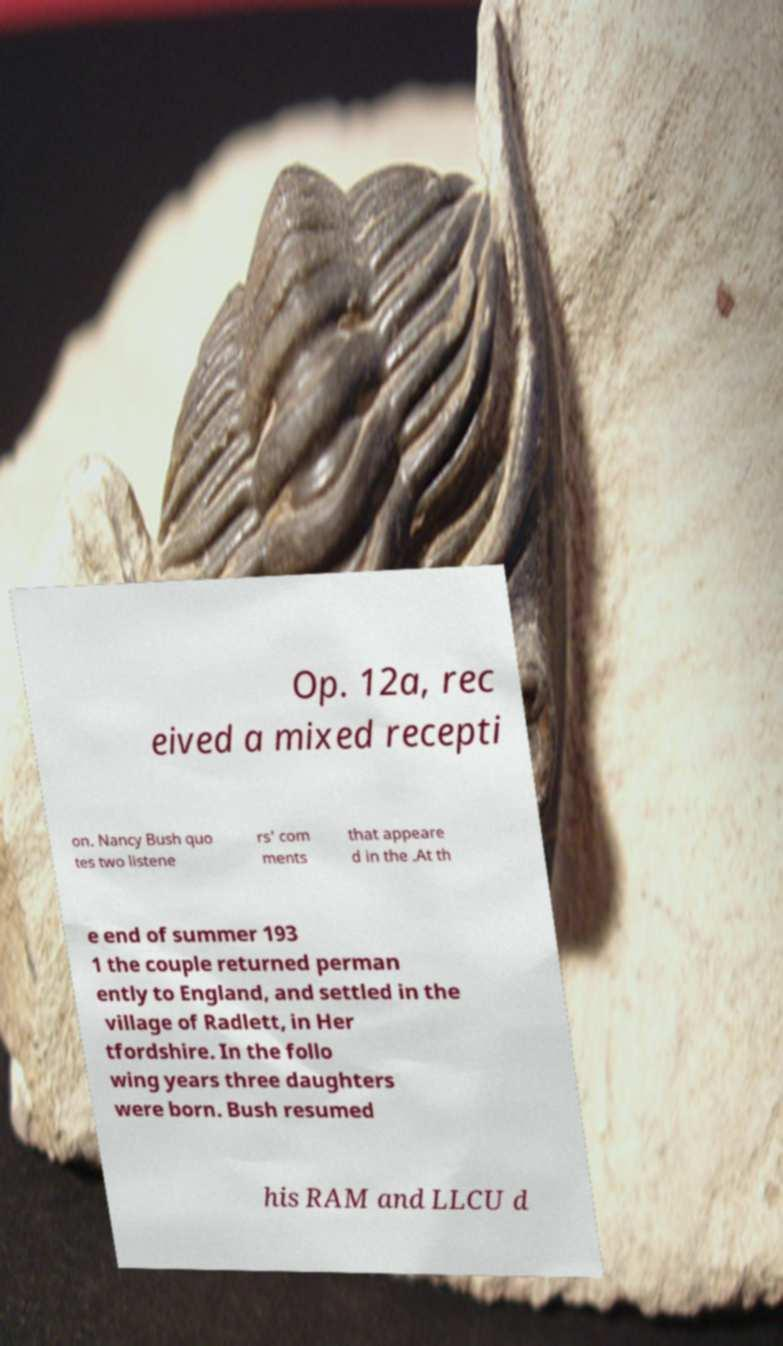Could you extract and type out the text from this image? Op. 12a, rec eived a mixed recepti on. Nancy Bush quo tes two listene rs' com ments that appeare d in the .At th e end of summer 193 1 the couple returned perman ently to England, and settled in the village of Radlett, in Her tfordshire. In the follo wing years three daughters were born. Bush resumed his RAM and LLCU d 